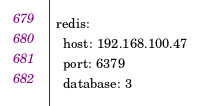Convert code to text. <code><loc_0><loc_0><loc_500><loc_500><_YAML_>
  redis:
    host: 192.168.100.47
    port: 6379
    database: 3
</code> 